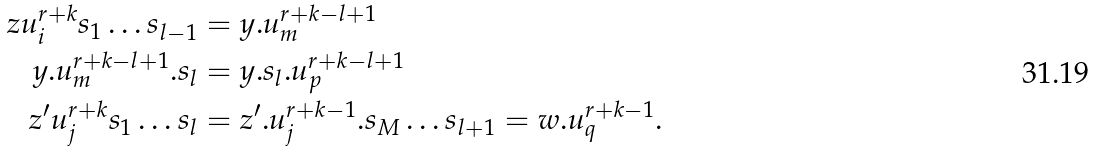<formula> <loc_0><loc_0><loc_500><loc_500>z u _ { i } ^ { r + k } s _ { 1 } \dots s _ { l - 1 } & = y . u _ { m } ^ { r + k - l + 1 } \\ y . u _ { m } ^ { r + k - l + 1 } . s _ { l } & = y . s _ { l } . u _ { p } ^ { r + k - l + 1 } \\ z ^ { \prime } u _ { j } ^ { r + k } s _ { 1 } \dots s _ { l } & = z ^ { \prime } . u _ { j } ^ { r + k - 1 } . s _ { M } \dots s _ { l + 1 } = w . u _ { q } ^ { r + k - 1 } .</formula> 